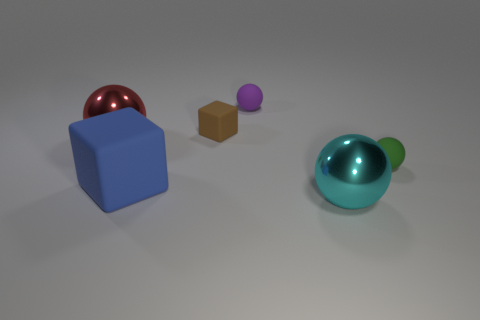The block that is the same size as the cyan thing is what color?
Your response must be concise. Blue. What shape is the small purple rubber object right of the big shiny sphere on the left side of the matte cube on the right side of the big blue matte object?
Your answer should be compact. Sphere. How many tiny green balls are behind the block behind the big red metallic sphere?
Offer a terse response. 0. There is a big metal thing that is on the left side of the small brown rubber cube; does it have the same shape as the small object left of the purple sphere?
Give a very brief answer. No. There is a blue thing; what number of large blue matte cubes are in front of it?
Make the answer very short. 0. Are the thing that is on the left side of the large block and the small purple ball made of the same material?
Give a very brief answer. No. What color is the other thing that is the same shape as the big blue thing?
Make the answer very short. Brown. The red shiny object has what shape?
Your answer should be very brief. Sphere. What number of things are either green things or big blue matte things?
Offer a very short reply. 2. How many other things are the same shape as the purple thing?
Provide a succinct answer. 3. 